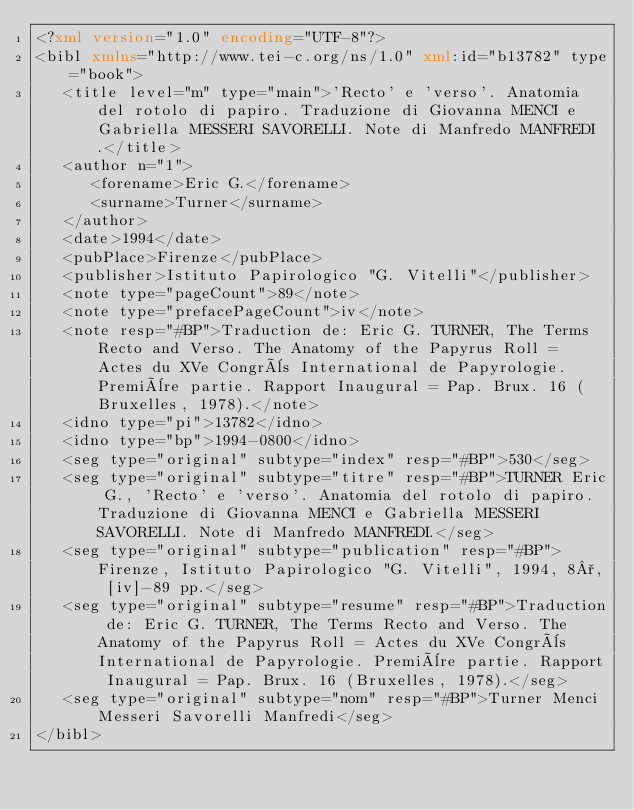Convert code to text. <code><loc_0><loc_0><loc_500><loc_500><_XML_><?xml version="1.0" encoding="UTF-8"?>
<bibl xmlns="http://www.tei-c.org/ns/1.0" xml:id="b13782" type="book">
   <title level="m" type="main">'Recto' e 'verso'. Anatomia del rotolo di papiro. Traduzione di Giovanna MENCI e Gabriella MESSERI SAVORELLI. Note di Manfredo MANFREDI.</title>
   <author n="1">
      <forename>Eric G.</forename>
      <surname>Turner</surname>
   </author>
   <date>1994</date>
   <pubPlace>Firenze</pubPlace>
   <publisher>Istituto Papirologico "G. Vitelli"</publisher>
   <note type="pageCount">89</note>
   <note type="prefacePageCount">iv</note>
   <note resp="#BP">Traduction de: Eric G. TURNER, The Terms Recto and Verso. The Anatomy of the Papyrus Roll = Actes du XVe Congrès International de Papyrologie. Première partie. Rapport Inaugural = Pap. Brux. 16 (Bruxelles, 1978).</note>
   <idno type="pi">13782</idno>
   <idno type="bp">1994-0800</idno>
   <seg type="original" subtype="index" resp="#BP">530</seg>
   <seg type="original" subtype="titre" resp="#BP">TURNER Eric G., 'Recto' e 'verso'. Anatomia del rotolo di papiro. Traduzione di Giovanna MENCI e Gabriella MESSERI SAVORELLI. Note di Manfredo MANFREDI.</seg>
   <seg type="original" subtype="publication" resp="#BP">Firenze, Istituto Papirologico "G. Vitelli", 1994, 8°, [iv]-89 pp.</seg>
   <seg type="original" subtype="resume" resp="#BP">Traduction de: Eric G. TURNER, The Terms Recto and Verso. The Anatomy of the Papyrus Roll = Actes du XVe Congrès International de Papyrologie. Première partie. Rapport Inaugural = Pap. Brux. 16 (Bruxelles, 1978).</seg>
   <seg type="original" subtype="nom" resp="#BP">Turner Menci Messeri Savorelli Manfredi</seg>
</bibl>
</code> 